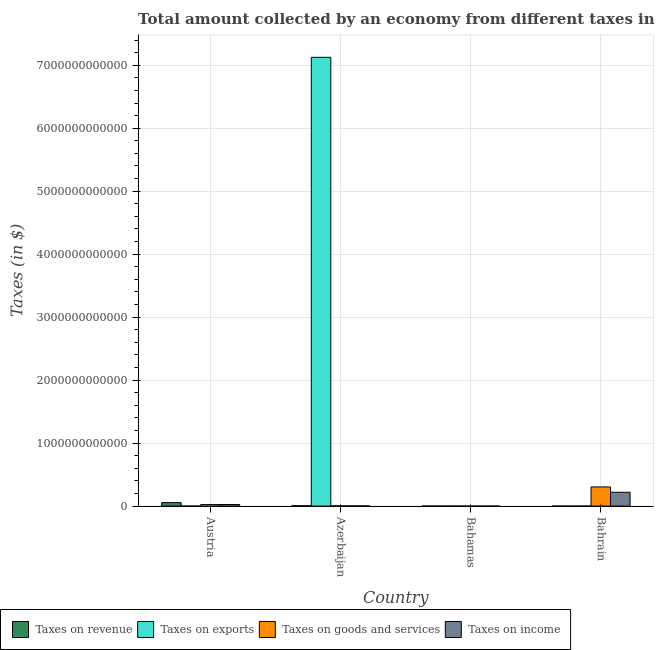How many different coloured bars are there?
Provide a succinct answer. 4. How many groups of bars are there?
Make the answer very short. 4. Are the number of bars per tick equal to the number of legend labels?
Your answer should be very brief. Yes. Are the number of bars on each tick of the X-axis equal?
Give a very brief answer. Yes. How many bars are there on the 4th tick from the left?
Give a very brief answer. 4. How many bars are there on the 2nd tick from the right?
Provide a short and direct response. 4. What is the amount collected as tax on exports in Austria?
Ensure brevity in your answer.  8000. Across all countries, what is the maximum amount collected as tax on goods?
Your answer should be compact. 3.04e+11. Across all countries, what is the minimum amount collected as tax on income?
Keep it short and to the point. 1.89e+07. In which country was the amount collected as tax on exports maximum?
Your response must be concise. Azerbaijan. In which country was the amount collected as tax on income minimum?
Your response must be concise. Bahamas. What is the total amount collected as tax on goods in the graph?
Make the answer very short. 3.32e+11. What is the difference between the amount collected as tax on income in Azerbaijan and that in Bahrain?
Provide a short and direct response. -2.17e+11. What is the difference between the amount collected as tax on income in Azerbaijan and the amount collected as tax on goods in Austria?
Give a very brief answer. -2.16e+1. What is the average amount collected as tax on revenue per country?
Give a very brief answer. 1.58e+1. What is the difference between the amount collected as tax on exports and amount collected as tax on goods in Bahamas?
Ensure brevity in your answer.  5.84e+08. What is the ratio of the amount collected as tax on exports in Bahamas to that in Bahrain?
Provide a succinct answer. 591.15. What is the difference between the highest and the second highest amount collected as tax on revenue?
Your answer should be very brief. 4.89e+1. What is the difference between the highest and the lowest amount collected as tax on goods?
Ensure brevity in your answer.  3.04e+11. Is the sum of the amount collected as tax on revenue in Austria and Bahamas greater than the maximum amount collected as tax on exports across all countries?
Your answer should be very brief. No. What does the 4th bar from the left in Bahamas represents?
Offer a terse response. Taxes on income. What does the 4th bar from the right in Bahamas represents?
Provide a short and direct response. Taxes on revenue. Is it the case that in every country, the sum of the amount collected as tax on revenue and amount collected as tax on exports is greater than the amount collected as tax on goods?
Your response must be concise. No. Are all the bars in the graph horizontal?
Your answer should be very brief. No. What is the difference between two consecutive major ticks on the Y-axis?
Your answer should be very brief. 1.00e+12. Are the values on the major ticks of Y-axis written in scientific E-notation?
Ensure brevity in your answer.  No. Does the graph contain any zero values?
Provide a short and direct response. No. Does the graph contain grids?
Offer a very short reply. Yes. How many legend labels are there?
Offer a terse response. 4. What is the title of the graph?
Ensure brevity in your answer.  Total amount collected by an economy from different taxes in 2011. Does "Forest" appear as one of the legend labels in the graph?
Make the answer very short. No. What is the label or title of the Y-axis?
Provide a succinct answer. Taxes (in $). What is the Taxes (in $) in Taxes on revenue in Austria?
Give a very brief answer. 5.52e+1. What is the Taxes (in $) of Taxes on exports in Austria?
Your answer should be very brief. 8000. What is the Taxes (in $) in Taxes on goods and services in Austria?
Offer a terse response. 2.45e+1. What is the Taxes (in $) of Taxes on income in Austria?
Give a very brief answer. 2.54e+1. What is the Taxes (in $) of Taxes on revenue in Azerbaijan?
Keep it short and to the point. 6.37e+09. What is the Taxes (in $) in Taxes on exports in Azerbaijan?
Provide a succinct answer. 7.13e+12. What is the Taxes (in $) in Taxes on goods and services in Azerbaijan?
Offer a very short reply. 2.87e+09. What is the Taxes (in $) of Taxes on income in Azerbaijan?
Give a very brief answer. 2.86e+09. What is the Taxes (in $) in Taxes on revenue in Bahamas?
Provide a short and direct response. 1.30e+09. What is the Taxes (in $) of Taxes on exports in Bahamas?
Make the answer very short. 8.04e+08. What is the Taxes (in $) in Taxes on goods and services in Bahamas?
Your answer should be very brief. 2.20e+08. What is the Taxes (in $) of Taxes on income in Bahamas?
Ensure brevity in your answer.  1.89e+07. What is the Taxes (in $) of Taxes on revenue in Bahrain?
Your response must be concise. 1.21e+08. What is the Taxes (in $) in Taxes on exports in Bahrain?
Your answer should be compact. 1.36e+06. What is the Taxes (in $) in Taxes on goods and services in Bahrain?
Your answer should be very brief. 3.04e+11. What is the Taxes (in $) of Taxes on income in Bahrain?
Provide a succinct answer. 2.20e+11. Across all countries, what is the maximum Taxes (in $) in Taxes on revenue?
Offer a terse response. 5.52e+1. Across all countries, what is the maximum Taxes (in $) of Taxes on exports?
Keep it short and to the point. 7.13e+12. Across all countries, what is the maximum Taxes (in $) in Taxes on goods and services?
Give a very brief answer. 3.04e+11. Across all countries, what is the maximum Taxes (in $) of Taxes on income?
Your answer should be very brief. 2.20e+11. Across all countries, what is the minimum Taxes (in $) of Taxes on revenue?
Your answer should be very brief. 1.21e+08. Across all countries, what is the minimum Taxes (in $) of Taxes on exports?
Your answer should be very brief. 8000. Across all countries, what is the minimum Taxes (in $) in Taxes on goods and services?
Ensure brevity in your answer.  2.20e+08. Across all countries, what is the minimum Taxes (in $) in Taxes on income?
Make the answer very short. 1.89e+07. What is the total Taxes (in $) in Taxes on revenue in the graph?
Your response must be concise. 6.30e+1. What is the total Taxes (in $) in Taxes on exports in the graph?
Offer a very short reply. 7.13e+12. What is the total Taxes (in $) in Taxes on goods and services in the graph?
Offer a terse response. 3.32e+11. What is the total Taxes (in $) of Taxes on income in the graph?
Make the answer very short. 2.48e+11. What is the difference between the Taxes (in $) in Taxes on revenue in Austria and that in Azerbaijan?
Keep it short and to the point. 4.89e+1. What is the difference between the Taxes (in $) of Taxes on exports in Austria and that in Azerbaijan?
Your answer should be very brief. -7.13e+12. What is the difference between the Taxes (in $) in Taxes on goods and services in Austria and that in Azerbaijan?
Provide a short and direct response. 2.16e+1. What is the difference between the Taxes (in $) in Taxes on income in Austria and that in Azerbaijan?
Make the answer very short. 2.25e+1. What is the difference between the Taxes (in $) in Taxes on revenue in Austria and that in Bahamas?
Offer a very short reply. 5.39e+1. What is the difference between the Taxes (in $) in Taxes on exports in Austria and that in Bahamas?
Your answer should be very brief. -8.04e+08. What is the difference between the Taxes (in $) in Taxes on goods and services in Austria and that in Bahamas?
Your answer should be very brief. 2.43e+1. What is the difference between the Taxes (in $) in Taxes on income in Austria and that in Bahamas?
Give a very brief answer. 2.54e+1. What is the difference between the Taxes (in $) of Taxes on revenue in Austria and that in Bahrain?
Offer a very short reply. 5.51e+1. What is the difference between the Taxes (in $) in Taxes on exports in Austria and that in Bahrain?
Offer a very short reply. -1.35e+06. What is the difference between the Taxes (in $) in Taxes on goods and services in Austria and that in Bahrain?
Give a very brief answer. -2.80e+11. What is the difference between the Taxes (in $) in Taxes on income in Austria and that in Bahrain?
Make the answer very short. -1.94e+11. What is the difference between the Taxes (in $) in Taxes on revenue in Azerbaijan and that in Bahamas?
Give a very brief answer. 5.07e+09. What is the difference between the Taxes (in $) of Taxes on exports in Azerbaijan and that in Bahamas?
Ensure brevity in your answer.  7.12e+12. What is the difference between the Taxes (in $) of Taxes on goods and services in Azerbaijan and that in Bahamas?
Offer a very short reply. 2.65e+09. What is the difference between the Taxes (in $) of Taxes on income in Azerbaijan and that in Bahamas?
Your answer should be very brief. 2.84e+09. What is the difference between the Taxes (in $) in Taxes on revenue in Azerbaijan and that in Bahrain?
Provide a succinct answer. 6.25e+09. What is the difference between the Taxes (in $) in Taxes on exports in Azerbaijan and that in Bahrain?
Offer a terse response. 7.13e+12. What is the difference between the Taxes (in $) in Taxes on goods and services in Azerbaijan and that in Bahrain?
Keep it short and to the point. -3.01e+11. What is the difference between the Taxes (in $) in Taxes on income in Azerbaijan and that in Bahrain?
Offer a very short reply. -2.17e+11. What is the difference between the Taxes (in $) in Taxes on revenue in Bahamas and that in Bahrain?
Your answer should be very brief. 1.18e+09. What is the difference between the Taxes (in $) in Taxes on exports in Bahamas and that in Bahrain?
Your answer should be very brief. 8.03e+08. What is the difference between the Taxes (in $) of Taxes on goods and services in Bahamas and that in Bahrain?
Offer a very short reply. -3.04e+11. What is the difference between the Taxes (in $) of Taxes on income in Bahamas and that in Bahrain?
Provide a succinct answer. -2.20e+11. What is the difference between the Taxes (in $) in Taxes on revenue in Austria and the Taxes (in $) in Taxes on exports in Azerbaijan?
Provide a short and direct response. -7.07e+12. What is the difference between the Taxes (in $) of Taxes on revenue in Austria and the Taxes (in $) of Taxes on goods and services in Azerbaijan?
Your response must be concise. 5.24e+1. What is the difference between the Taxes (in $) of Taxes on revenue in Austria and the Taxes (in $) of Taxes on income in Azerbaijan?
Provide a short and direct response. 5.24e+1. What is the difference between the Taxes (in $) in Taxes on exports in Austria and the Taxes (in $) in Taxes on goods and services in Azerbaijan?
Your answer should be compact. -2.87e+09. What is the difference between the Taxes (in $) in Taxes on exports in Austria and the Taxes (in $) in Taxes on income in Azerbaijan?
Offer a terse response. -2.86e+09. What is the difference between the Taxes (in $) of Taxes on goods and services in Austria and the Taxes (in $) of Taxes on income in Azerbaijan?
Your answer should be compact. 2.16e+1. What is the difference between the Taxes (in $) in Taxes on revenue in Austria and the Taxes (in $) in Taxes on exports in Bahamas?
Ensure brevity in your answer.  5.44e+1. What is the difference between the Taxes (in $) of Taxes on revenue in Austria and the Taxes (in $) of Taxes on goods and services in Bahamas?
Your answer should be very brief. 5.50e+1. What is the difference between the Taxes (in $) of Taxes on revenue in Austria and the Taxes (in $) of Taxes on income in Bahamas?
Offer a very short reply. 5.52e+1. What is the difference between the Taxes (in $) in Taxes on exports in Austria and the Taxes (in $) in Taxes on goods and services in Bahamas?
Your answer should be compact. -2.20e+08. What is the difference between the Taxes (in $) in Taxes on exports in Austria and the Taxes (in $) in Taxes on income in Bahamas?
Offer a very short reply. -1.89e+07. What is the difference between the Taxes (in $) in Taxes on goods and services in Austria and the Taxes (in $) in Taxes on income in Bahamas?
Provide a short and direct response. 2.45e+1. What is the difference between the Taxes (in $) of Taxes on revenue in Austria and the Taxes (in $) of Taxes on exports in Bahrain?
Keep it short and to the point. 5.52e+1. What is the difference between the Taxes (in $) of Taxes on revenue in Austria and the Taxes (in $) of Taxes on goods and services in Bahrain?
Give a very brief answer. -2.49e+11. What is the difference between the Taxes (in $) of Taxes on revenue in Austria and the Taxes (in $) of Taxes on income in Bahrain?
Your answer should be very brief. -1.64e+11. What is the difference between the Taxes (in $) of Taxes on exports in Austria and the Taxes (in $) of Taxes on goods and services in Bahrain?
Give a very brief answer. -3.04e+11. What is the difference between the Taxes (in $) of Taxes on exports in Austria and the Taxes (in $) of Taxes on income in Bahrain?
Your response must be concise. -2.20e+11. What is the difference between the Taxes (in $) of Taxes on goods and services in Austria and the Taxes (in $) of Taxes on income in Bahrain?
Make the answer very short. -1.95e+11. What is the difference between the Taxes (in $) in Taxes on revenue in Azerbaijan and the Taxes (in $) in Taxes on exports in Bahamas?
Ensure brevity in your answer.  5.56e+09. What is the difference between the Taxes (in $) of Taxes on revenue in Azerbaijan and the Taxes (in $) of Taxes on goods and services in Bahamas?
Your response must be concise. 6.15e+09. What is the difference between the Taxes (in $) of Taxes on revenue in Azerbaijan and the Taxes (in $) of Taxes on income in Bahamas?
Keep it short and to the point. 6.35e+09. What is the difference between the Taxes (in $) in Taxes on exports in Azerbaijan and the Taxes (in $) in Taxes on goods and services in Bahamas?
Your answer should be compact. 7.13e+12. What is the difference between the Taxes (in $) in Taxes on exports in Azerbaijan and the Taxes (in $) in Taxes on income in Bahamas?
Your answer should be very brief. 7.13e+12. What is the difference between the Taxes (in $) in Taxes on goods and services in Azerbaijan and the Taxes (in $) in Taxes on income in Bahamas?
Your answer should be compact. 2.85e+09. What is the difference between the Taxes (in $) in Taxes on revenue in Azerbaijan and the Taxes (in $) in Taxes on exports in Bahrain?
Your answer should be very brief. 6.37e+09. What is the difference between the Taxes (in $) of Taxes on revenue in Azerbaijan and the Taxes (in $) of Taxes on goods and services in Bahrain?
Your answer should be compact. -2.98e+11. What is the difference between the Taxes (in $) of Taxes on revenue in Azerbaijan and the Taxes (in $) of Taxes on income in Bahrain?
Offer a terse response. -2.13e+11. What is the difference between the Taxes (in $) in Taxes on exports in Azerbaijan and the Taxes (in $) in Taxes on goods and services in Bahrain?
Provide a short and direct response. 6.82e+12. What is the difference between the Taxes (in $) in Taxes on exports in Azerbaijan and the Taxes (in $) in Taxes on income in Bahrain?
Your answer should be compact. 6.91e+12. What is the difference between the Taxes (in $) of Taxes on goods and services in Azerbaijan and the Taxes (in $) of Taxes on income in Bahrain?
Provide a short and direct response. -2.17e+11. What is the difference between the Taxes (in $) in Taxes on revenue in Bahamas and the Taxes (in $) in Taxes on exports in Bahrain?
Keep it short and to the point. 1.30e+09. What is the difference between the Taxes (in $) in Taxes on revenue in Bahamas and the Taxes (in $) in Taxes on goods and services in Bahrain?
Offer a terse response. -3.03e+11. What is the difference between the Taxes (in $) of Taxes on revenue in Bahamas and the Taxes (in $) of Taxes on income in Bahrain?
Keep it short and to the point. -2.18e+11. What is the difference between the Taxes (in $) in Taxes on exports in Bahamas and the Taxes (in $) in Taxes on goods and services in Bahrain?
Make the answer very short. -3.03e+11. What is the difference between the Taxes (in $) in Taxes on exports in Bahamas and the Taxes (in $) in Taxes on income in Bahrain?
Your response must be concise. -2.19e+11. What is the difference between the Taxes (in $) in Taxes on goods and services in Bahamas and the Taxes (in $) in Taxes on income in Bahrain?
Provide a short and direct response. -2.19e+11. What is the average Taxes (in $) in Taxes on revenue per country?
Make the answer very short. 1.58e+1. What is the average Taxes (in $) of Taxes on exports per country?
Offer a very short reply. 1.78e+12. What is the average Taxes (in $) of Taxes on goods and services per country?
Provide a succinct answer. 8.29e+1. What is the average Taxes (in $) of Taxes on income per country?
Keep it short and to the point. 6.20e+1. What is the difference between the Taxes (in $) in Taxes on revenue and Taxes (in $) in Taxes on exports in Austria?
Your answer should be compact. 5.52e+1. What is the difference between the Taxes (in $) of Taxes on revenue and Taxes (in $) of Taxes on goods and services in Austria?
Make the answer very short. 3.07e+1. What is the difference between the Taxes (in $) in Taxes on revenue and Taxes (in $) in Taxes on income in Austria?
Provide a short and direct response. 2.98e+1. What is the difference between the Taxes (in $) in Taxes on exports and Taxes (in $) in Taxes on goods and services in Austria?
Your answer should be compact. -2.45e+1. What is the difference between the Taxes (in $) of Taxes on exports and Taxes (in $) of Taxes on income in Austria?
Your answer should be compact. -2.54e+1. What is the difference between the Taxes (in $) in Taxes on goods and services and Taxes (in $) in Taxes on income in Austria?
Provide a succinct answer. -8.95e+08. What is the difference between the Taxes (in $) in Taxes on revenue and Taxes (in $) in Taxes on exports in Azerbaijan?
Ensure brevity in your answer.  -7.12e+12. What is the difference between the Taxes (in $) of Taxes on revenue and Taxes (in $) of Taxes on goods and services in Azerbaijan?
Keep it short and to the point. 3.50e+09. What is the difference between the Taxes (in $) in Taxes on revenue and Taxes (in $) in Taxes on income in Azerbaijan?
Provide a succinct answer. 3.51e+09. What is the difference between the Taxes (in $) of Taxes on exports and Taxes (in $) of Taxes on goods and services in Azerbaijan?
Offer a terse response. 7.12e+12. What is the difference between the Taxes (in $) in Taxes on exports and Taxes (in $) in Taxes on income in Azerbaijan?
Your response must be concise. 7.12e+12. What is the difference between the Taxes (in $) of Taxes on goods and services and Taxes (in $) of Taxes on income in Azerbaijan?
Ensure brevity in your answer.  3.50e+06. What is the difference between the Taxes (in $) of Taxes on revenue and Taxes (in $) of Taxes on exports in Bahamas?
Offer a terse response. 4.93e+08. What is the difference between the Taxes (in $) of Taxes on revenue and Taxes (in $) of Taxes on goods and services in Bahamas?
Keep it short and to the point. 1.08e+09. What is the difference between the Taxes (in $) in Taxes on revenue and Taxes (in $) in Taxes on income in Bahamas?
Give a very brief answer. 1.28e+09. What is the difference between the Taxes (in $) of Taxes on exports and Taxes (in $) of Taxes on goods and services in Bahamas?
Provide a succinct answer. 5.84e+08. What is the difference between the Taxes (in $) of Taxes on exports and Taxes (in $) of Taxes on income in Bahamas?
Your answer should be compact. 7.85e+08. What is the difference between the Taxes (in $) of Taxes on goods and services and Taxes (in $) of Taxes on income in Bahamas?
Make the answer very short. 2.01e+08. What is the difference between the Taxes (in $) of Taxes on revenue and Taxes (in $) of Taxes on exports in Bahrain?
Your answer should be compact. 1.19e+08. What is the difference between the Taxes (in $) in Taxes on revenue and Taxes (in $) in Taxes on goods and services in Bahrain?
Give a very brief answer. -3.04e+11. What is the difference between the Taxes (in $) in Taxes on revenue and Taxes (in $) in Taxes on income in Bahrain?
Keep it short and to the point. -2.20e+11. What is the difference between the Taxes (in $) of Taxes on exports and Taxes (in $) of Taxes on goods and services in Bahrain?
Make the answer very short. -3.04e+11. What is the difference between the Taxes (in $) in Taxes on exports and Taxes (in $) in Taxes on income in Bahrain?
Ensure brevity in your answer.  -2.20e+11. What is the difference between the Taxes (in $) in Taxes on goods and services and Taxes (in $) in Taxes on income in Bahrain?
Provide a succinct answer. 8.44e+1. What is the ratio of the Taxes (in $) of Taxes on revenue in Austria to that in Azerbaijan?
Your answer should be compact. 8.67. What is the ratio of the Taxes (in $) of Taxes on exports in Austria to that in Azerbaijan?
Keep it short and to the point. 0. What is the ratio of the Taxes (in $) in Taxes on goods and services in Austria to that in Azerbaijan?
Provide a short and direct response. 8.55. What is the ratio of the Taxes (in $) of Taxes on income in Austria to that in Azerbaijan?
Give a very brief answer. 8.88. What is the ratio of the Taxes (in $) in Taxes on revenue in Austria to that in Bahamas?
Provide a succinct answer. 42.59. What is the ratio of the Taxes (in $) in Taxes on exports in Austria to that in Bahamas?
Offer a terse response. 0. What is the ratio of the Taxes (in $) in Taxes on goods and services in Austria to that in Bahamas?
Your response must be concise. 111.5. What is the ratio of the Taxes (in $) in Taxes on income in Austria to that in Bahamas?
Provide a short and direct response. 1345.3. What is the ratio of the Taxes (in $) in Taxes on revenue in Austria to that in Bahrain?
Offer a terse response. 458.16. What is the ratio of the Taxes (in $) of Taxes on exports in Austria to that in Bahrain?
Make the answer very short. 0.01. What is the ratio of the Taxes (in $) in Taxes on goods and services in Austria to that in Bahrain?
Provide a succinct answer. 0.08. What is the ratio of the Taxes (in $) in Taxes on income in Austria to that in Bahrain?
Your answer should be very brief. 0.12. What is the ratio of the Taxes (in $) in Taxes on revenue in Azerbaijan to that in Bahamas?
Your response must be concise. 4.91. What is the ratio of the Taxes (in $) in Taxes on exports in Azerbaijan to that in Bahamas?
Offer a very short reply. 8862.99. What is the ratio of the Taxes (in $) of Taxes on goods and services in Azerbaijan to that in Bahamas?
Offer a terse response. 13.04. What is the ratio of the Taxes (in $) of Taxes on income in Azerbaijan to that in Bahamas?
Offer a very short reply. 151.55. What is the ratio of the Taxes (in $) of Taxes on revenue in Azerbaijan to that in Bahrain?
Your response must be concise. 52.81. What is the ratio of the Taxes (in $) of Taxes on exports in Azerbaijan to that in Bahrain?
Ensure brevity in your answer.  5.24e+06. What is the ratio of the Taxes (in $) in Taxes on goods and services in Azerbaijan to that in Bahrain?
Provide a succinct answer. 0.01. What is the ratio of the Taxes (in $) in Taxes on income in Azerbaijan to that in Bahrain?
Keep it short and to the point. 0.01. What is the ratio of the Taxes (in $) in Taxes on revenue in Bahamas to that in Bahrain?
Ensure brevity in your answer.  10.76. What is the ratio of the Taxes (in $) of Taxes on exports in Bahamas to that in Bahrain?
Your answer should be very brief. 591.15. What is the ratio of the Taxes (in $) in Taxes on goods and services in Bahamas to that in Bahrain?
Make the answer very short. 0. What is the difference between the highest and the second highest Taxes (in $) in Taxes on revenue?
Ensure brevity in your answer.  4.89e+1. What is the difference between the highest and the second highest Taxes (in $) of Taxes on exports?
Make the answer very short. 7.12e+12. What is the difference between the highest and the second highest Taxes (in $) in Taxes on goods and services?
Offer a very short reply. 2.80e+11. What is the difference between the highest and the second highest Taxes (in $) of Taxes on income?
Offer a very short reply. 1.94e+11. What is the difference between the highest and the lowest Taxes (in $) in Taxes on revenue?
Give a very brief answer. 5.51e+1. What is the difference between the highest and the lowest Taxes (in $) in Taxes on exports?
Offer a terse response. 7.13e+12. What is the difference between the highest and the lowest Taxes (in $) of Taxes on goods and services?
Ensure brevity in your answer.  3.04e+11. What is the difference between the highest and the lowest Taxes (in $) of Taxes on income?
Your answer should be very brief. 2.20e+11. 